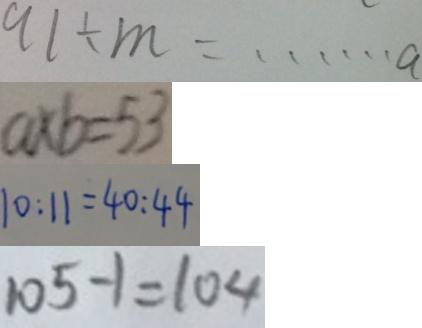Convert formula to latex. <formula><loc_0><loc_0><loc_500><loc_500>9 1 \div m = \cdots a 
 a \times b = 5 3 
 1 0 : 1 1 = 4 0 : 4 4 
 1 0 5 - 1 = 1 0 4</formula> 